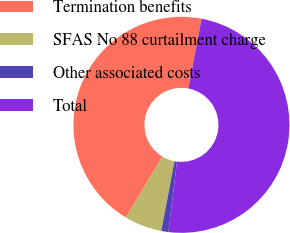Convert chart. <chart><loc_0><loc_0><loc_500><loc_500><pie_chart><fcel>Termination benefits<fcel>SFAS No 88 curtailment charge<fcel>Other associated costs<fcel>Total<nl><fcel>44.39%<fcel>5.61%<fcel>1.06%<fcel>48.94%<nl></chart> 